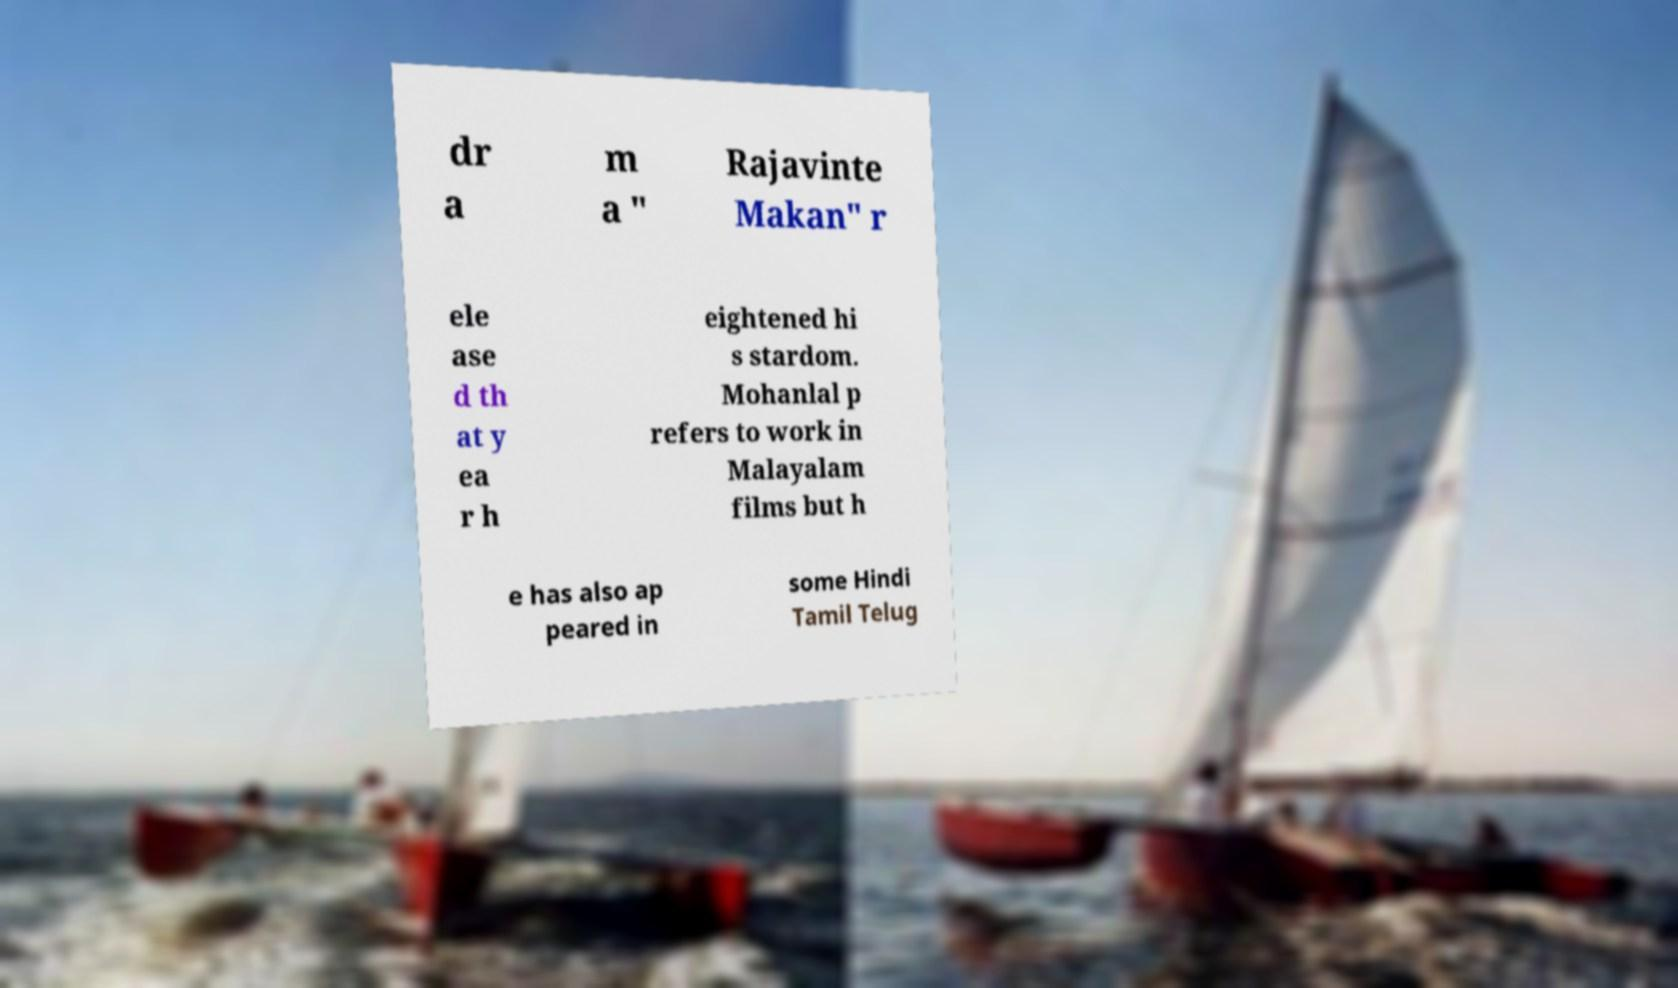Could you assist in decoding the text presented in this image and type it out clearly? dr a m a " Rajavinte Makan" r ele ase d th at y ea r h eightened hi s stardom. Mohanlal p refers to work in Malayalam films but h e has also ap peared in some Hindi Tamil Telug 